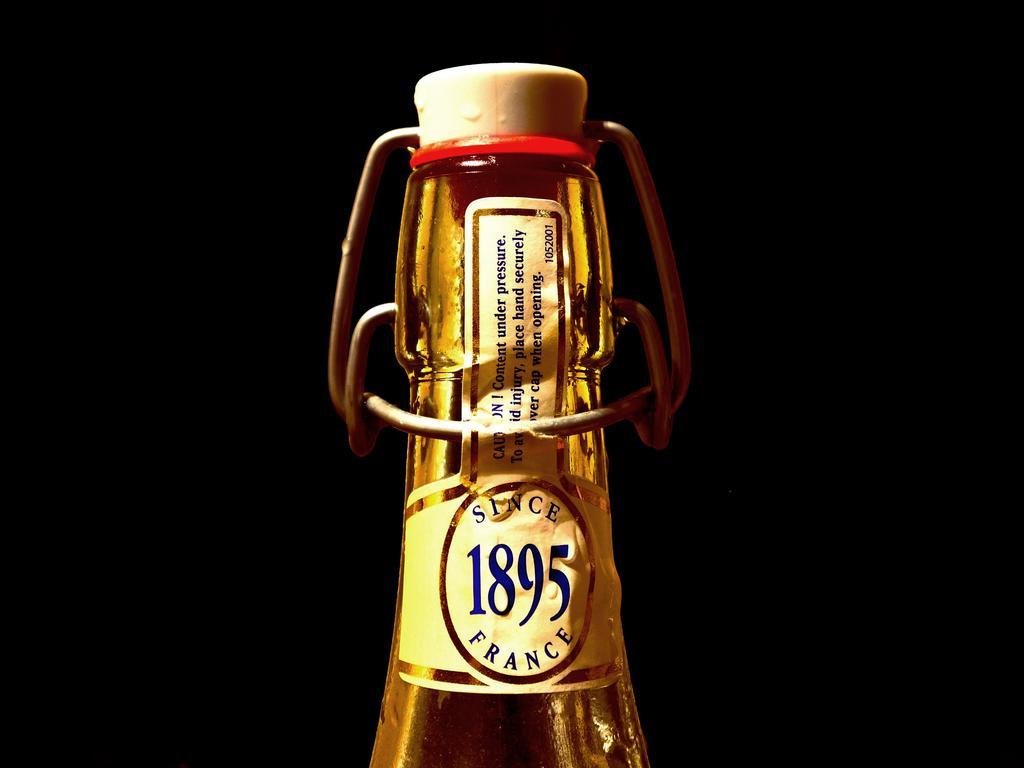Could you give a brief overview of what you see in this image? In this picture we can see bottle with sticker and cap and in background it is dark. 